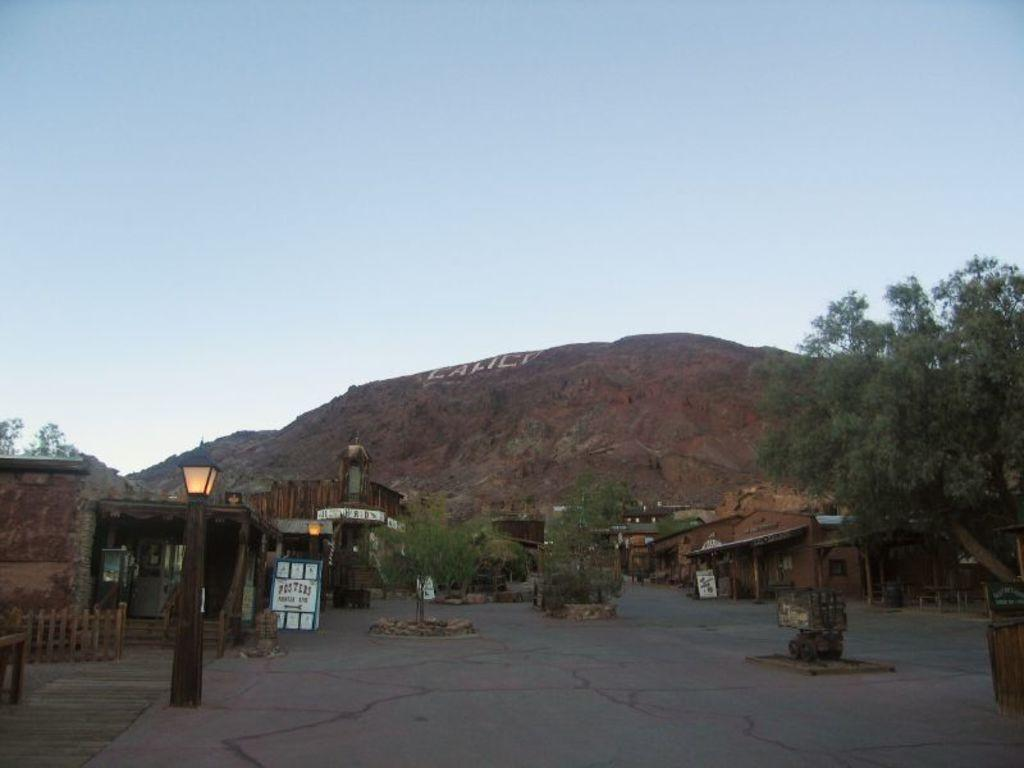What can be seen in the background of the image? The sky is visible in the background of the image. What type of structures are present in the image? There are houses in the image. What other natural elements can be seen in the image? There are trees in the image. What objects are made of wood in the image? There are boards in the image. Where are the lights located in the image? Lights are present on the left side of the image. How many pages are visible in the image? There are no pages present in the image. What type of sponge can be seen cleaning the boards in the image? There is no sponge visible in the image, and the boards do not appear to be cleaned. 